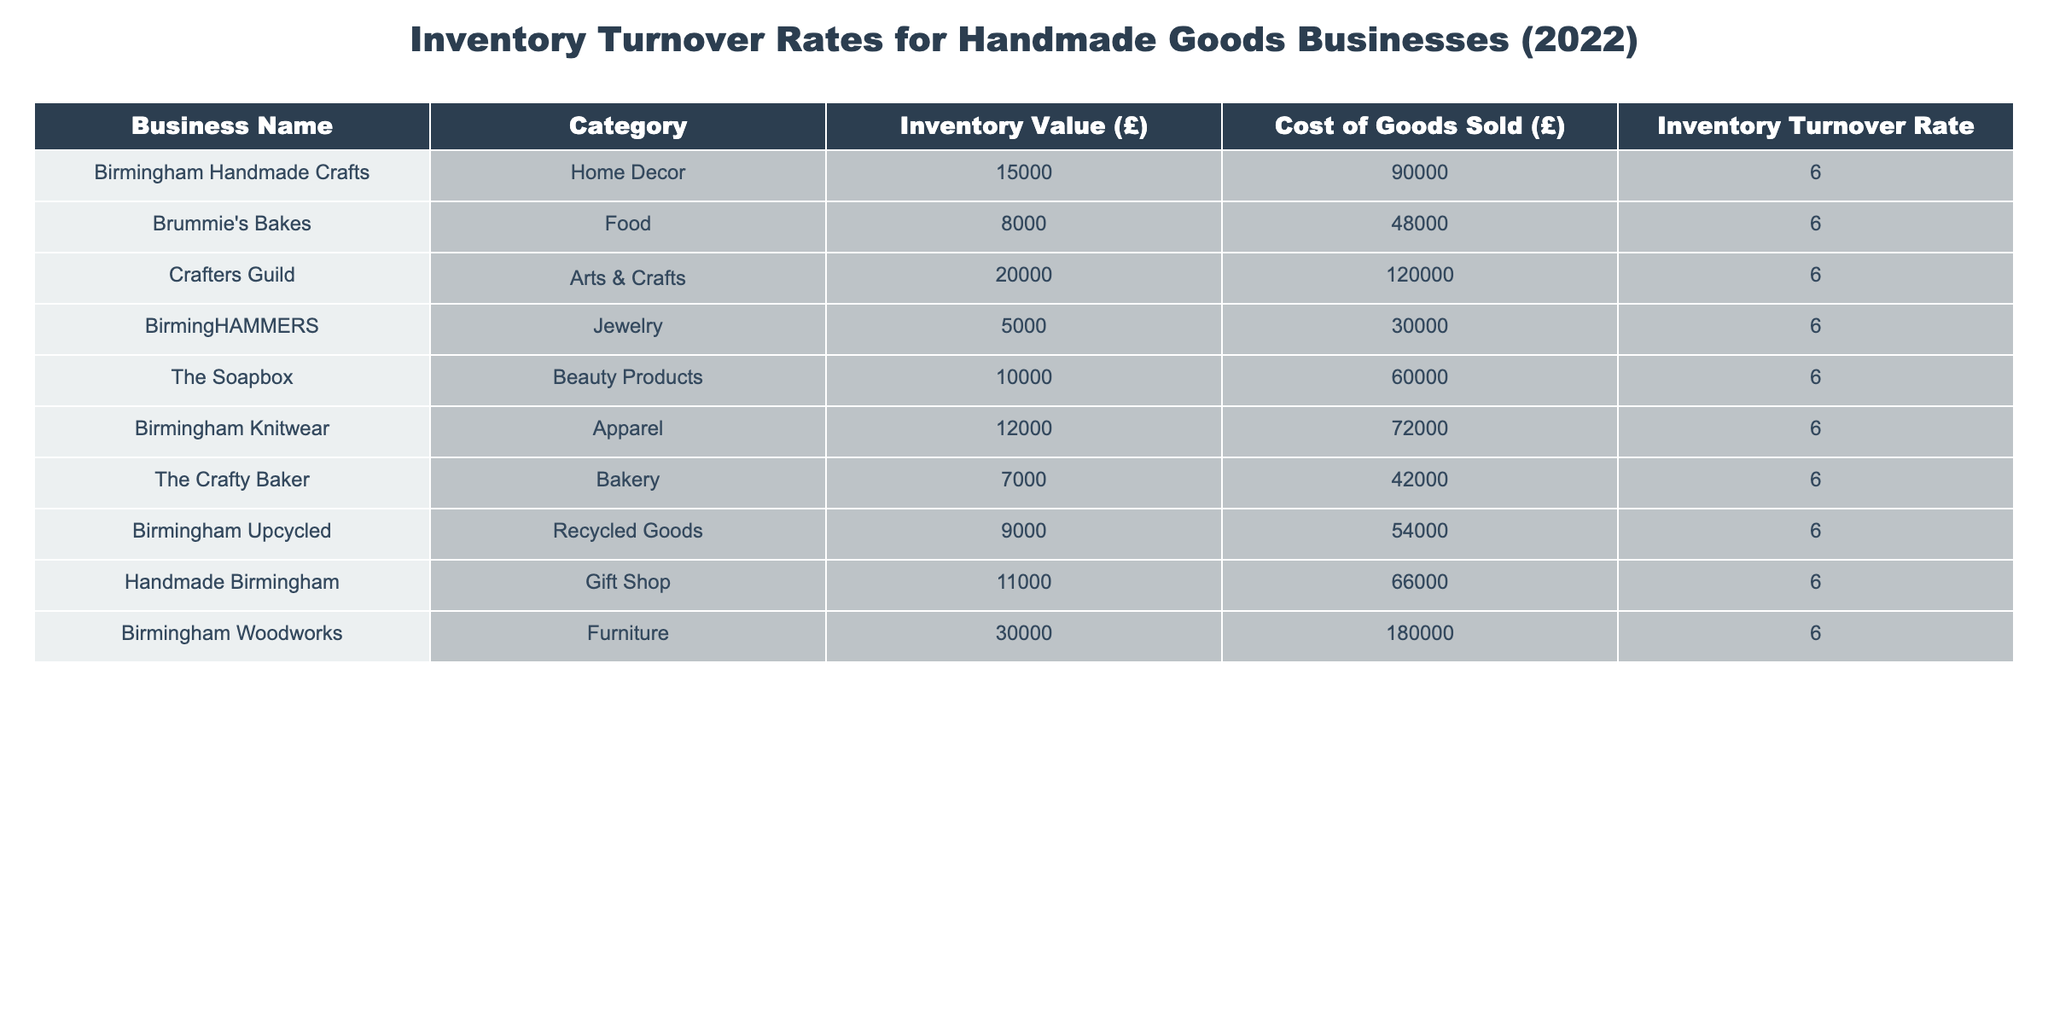What is the inventory turnover rate for Birmingham Handmade Crafts? The table explicitly lists Birmingham Handmade Crafts with an inventory turnover rate of 6.0.
Answer: 6.0 Which business has the highest inventory value? By comparing the 'Inventory Value (£)' column, Birmingham Woodworks has the highest value at £30,000.
Answer: Birmingham Woodworks Is the inventory turnover rate consistent across all businesses? Yes, all businesses listed show the same inventory turnover rate of 6.0, indicating consistency.
Answer: Yes What is the total inventory value of all businesses combined? Adding all inventory values: 15000 + 8000 + 20000 + 5000 + 10000 + 12000 + 7000 + 9000 + 11000 + 30000 = £1,10,000.
Answer: £110,000 How many businesses fall within the Apparel category? There is one business in the Apparel category, which is Birmingham Knitwear.
Answer: 1 What is the relationship between Cost of Goods Sold and Inventory Value in this table? The table indicates that all businesses have a Cost of Goods Sold that is consistently significantly higher than their Inventory Value, indicating a high sales volume relative to inventory.
Answer: Higher What would be the average cost of goods sold across all businesses? The total cost of goods sold is 90000 + 48000 + 120000 + 30000 + 60000 + 72000 + 42000 + 54000 + 66000 + 180000 = 630000. Divided by the number of businesses (10), the average is 63000.
Answer: £63,000 If we consider the Inventory Value, which business has the lowest value? BirmingHAMMERS has the lowest inventory value at £5,000.
Answer: BirmingHAMMERS How much does Birmingham Upcycled's cost of goods sold represent as a percentage of its inventory value? The Cost of Goods Sold for Birmingham Upcycled is £54,000, and the Inventory Value is £9,000. So, (54000 / 9000) * 100 = 600%.
Answer: 600% Which category has the largest cumulative inventory value? By summing up the inventory values for each category: Home Decor (15,000), Food (8,000), Arts & Crafts (20,000), Jewelry (5,000), Beauty Products (10,000), Apparel (12,000), Bakery (7,000), Recycled Goods (9,000), Gift Shop (11,000), Furniture (30,000), the Furniture category has the largest value at £30,000.
Answer: Furniture 